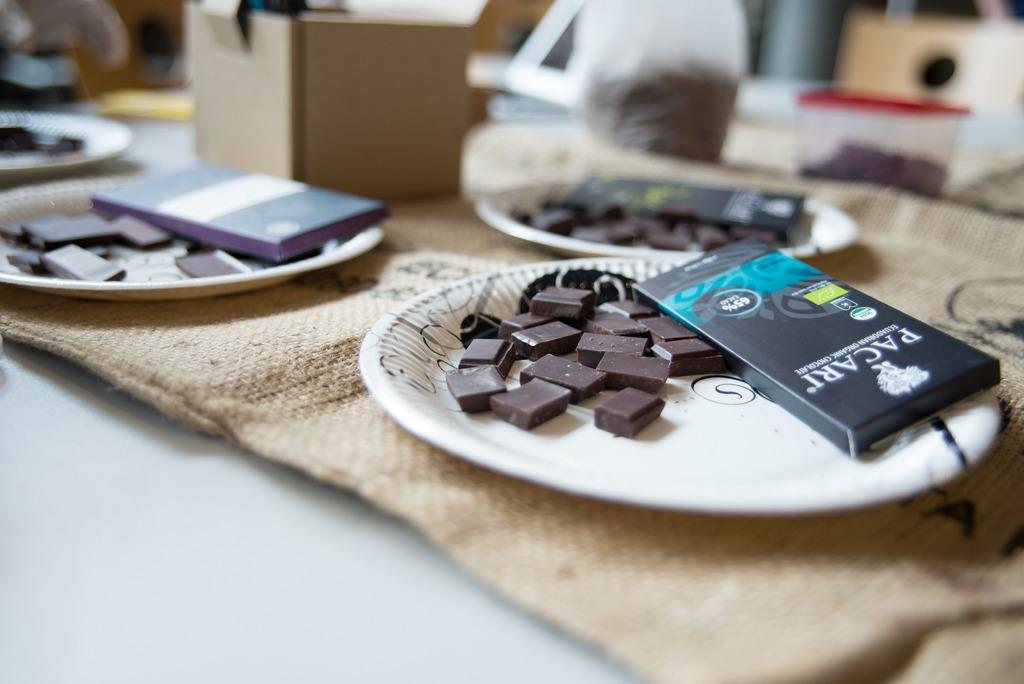<image>
Present a compact description of the photo's key features. A box of chocolate from Pacari lays on a paper plate along side some chocolate squares. 